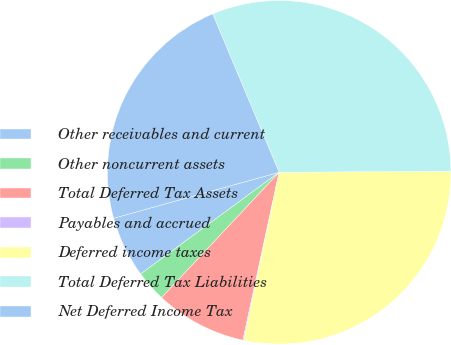<chart> <loc_0><loc_0><loc_500><loc_500><pie_chart><fcel>Other receivables and current<fcel>Other noncurrent assets<fcel>Total Deferred Tax Assets<fcel>Payables and accrued<fcel>Deferred income taxes<fcel>Total Deferred Tax Liabilities<fcel>Net Deferred Income Tax<nl><fcel>5.77%<fcel>2.93%<fcel>8.61%<fcel>0.09%<fcel>28.39%<fcel>31.23%<fcel>22.99%<nl></chart> 